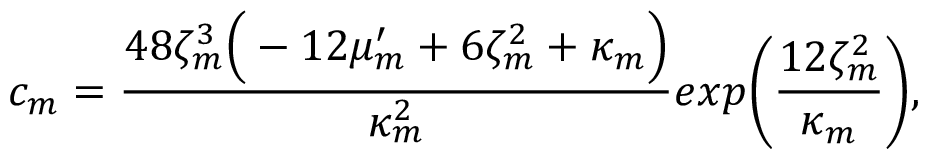Convert formula to latex. <formula><loc_0><loc_0><loc_500><loc_500>c _ { m } = \frac { 4 8 \zeta _ { m } ^ { 3 } \left ( - 1 2 \mu _ { m } ^ { \prime } + 6 \zeta _ { m } ^ { 2 } + \kappa _ { m } \right ) } { \kappa _ { m } ^ { 2 } } e x p \left ( \frac { 1 2 \zeta _ { m } ^ { 2 } } { \kappa _ { m } } \right ) ,</formula> 